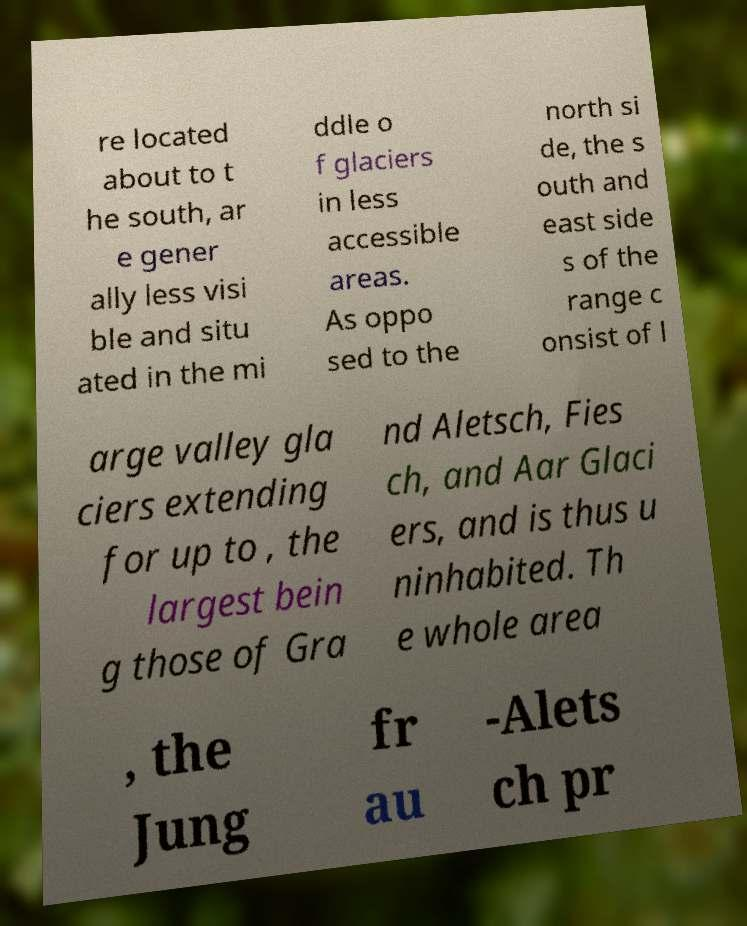Could you extract and type out the text from this image? re located about to t he south, ar e gener ally less visi ble and situ ated in the mi ddle o f glaciers in less accessible areas. As oppo sed to the north si de, the s outh and east side s of the range c onsist of l arge valley gla ciers extending for up to , the largest bein g those of Gra nd Aletsch, Fies ch, and Aar Glaci ers, and is thus u ninhabited. Th e whole area , the Jung fr au -Alets ch pr 